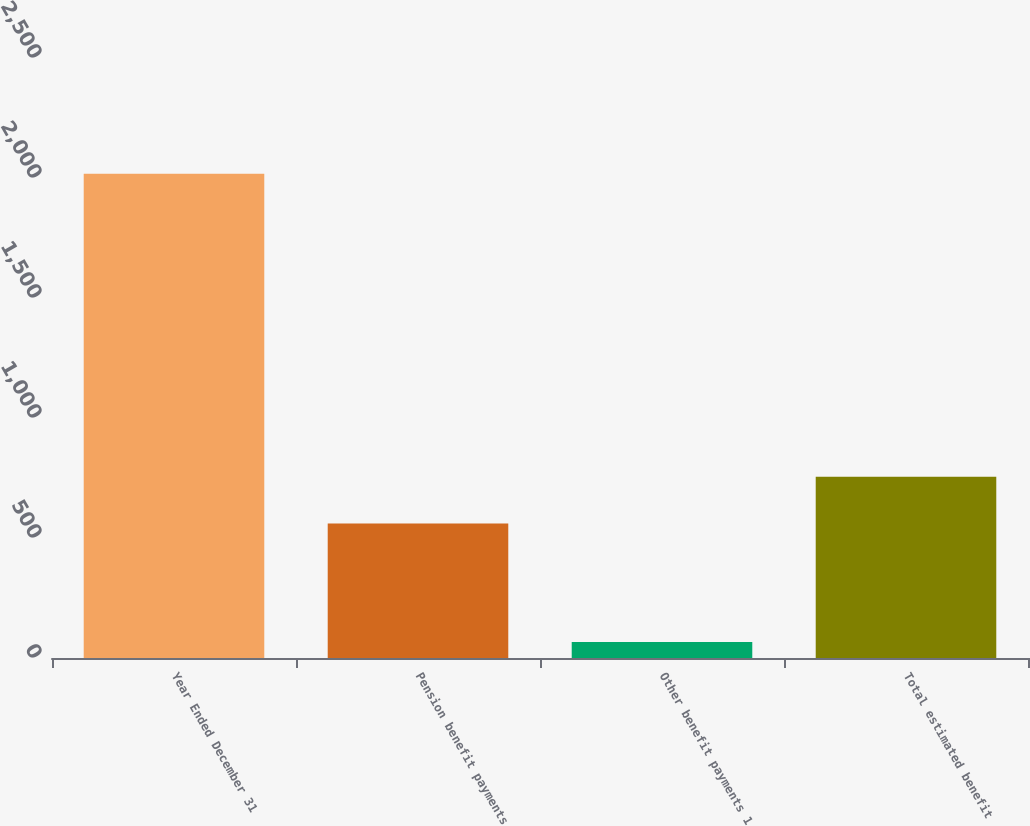<chart> <loc_0><loc_0><loc_500><loc_500><bar_chart><fcel>Year Ended December 31<fcel>Pension benefit payments<fcel>Other benefit payments 1<fcel>Total estimated benefit<nl><fcel>2018<fcel>560<fcel>67<fcel>755.1<nl></chart> 